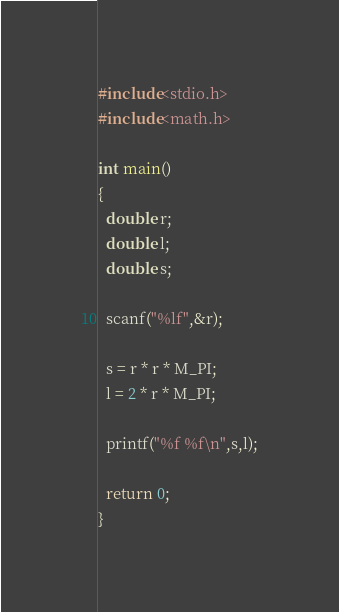<code> <loc_0><loc_0><loc_500><loc_500><_C_>#include<stdio.h>
#include<math.h>

int main()
{
  double r;
  double l;
  double s;

  scanf("%lf",&r);

  s = r * r * M_PI;
  l = 2 * r * M_PI;

  printf("%f %f\n",s,l);

  return 0;
}</code> 